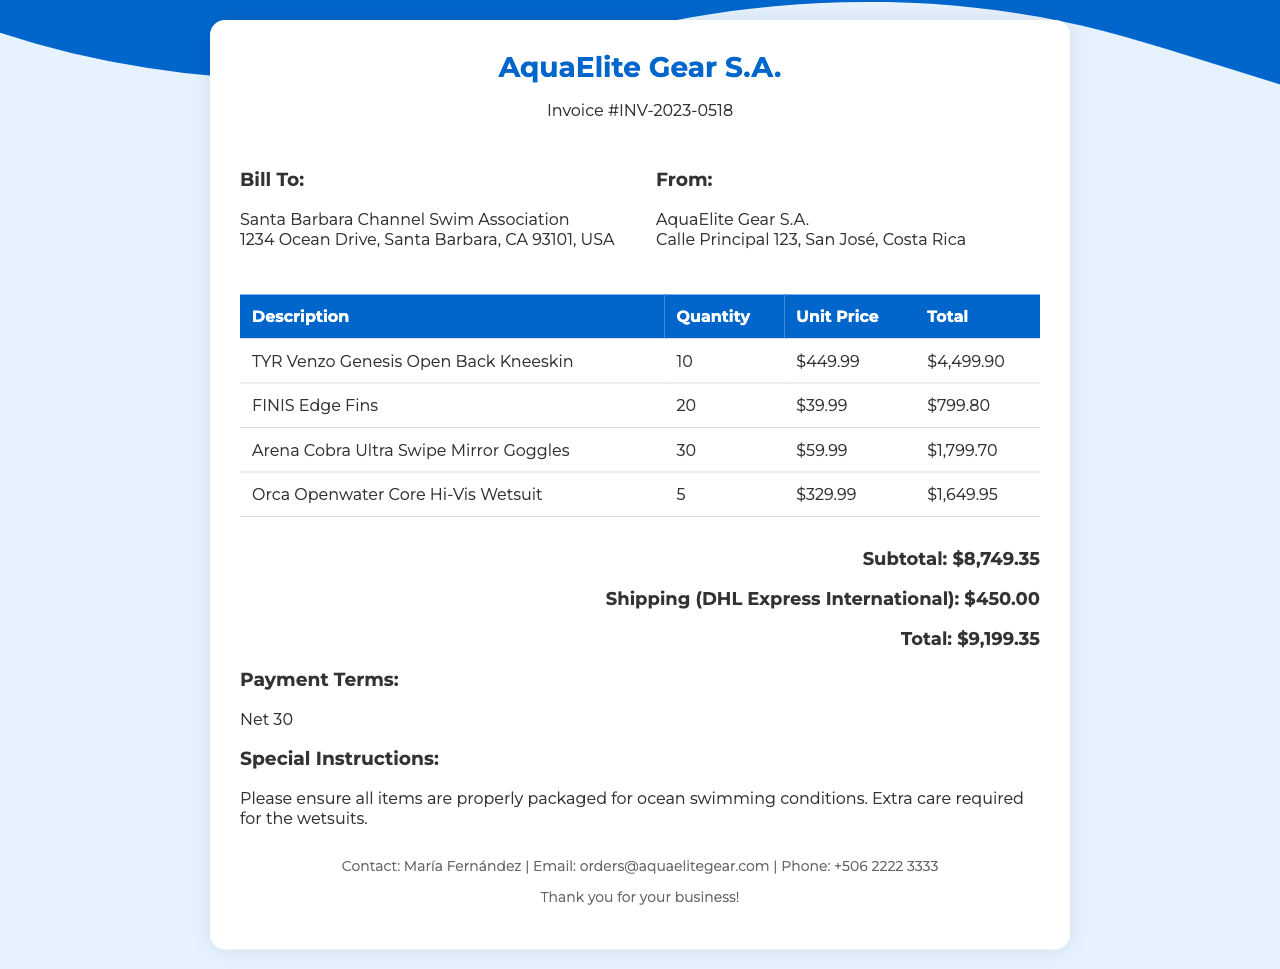What is the invoice number? The invoice number is clearly stated in the document to identify it uniquely.
Answer: INV-2023-0518 Who is the billing recipient? The billing recipient is mentioned prominently, identifying the organization receiving the invoice.
Answer: Santa Barbara Channel Swim Association What is the subtotal amount? The subtotal is a calculation of all items before shipping costs are added.
Answer: $8,749.35 How many TYR Venzo Genesis Open Back Kneeskins were ordered? The document lists the quantity of each item ordered in its itemized list.
Answer: 10 What shipping method is used? The shipping method is specified in the document for clarity on how the order will be delivered.
Answer: DHL Express International What is the total amount due? The total amount calculated includes all items and shipping costs, clearly stated at the end.
Answer: $9,199.35 What special instruction is provided for shipping? Specific instructions ensure the proper handling of the sensitive items during shipping.
Answer: Extra care required for the wetsuits How many Arena Cobra Ultra Swipe Mirror Goggles were included in the order? The document lists the quantity of each item in the order, including goggles.
Answer: 30 What are the payment terms listed in the invoice? The payment terms indicate how soon payment should be made after receiving the invoice.
Answer: Net 30 